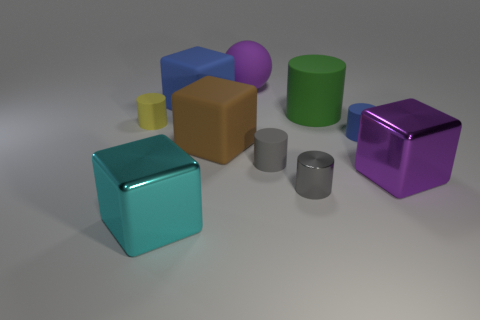What size is the green rubber object that is the same shape as the small gray matte thing? The green rubber object that shares its cylindrical shape with the small gray matte item appears to be large compared to the gray one, suggesting it is the largest size present among the similar-shaped objects. 